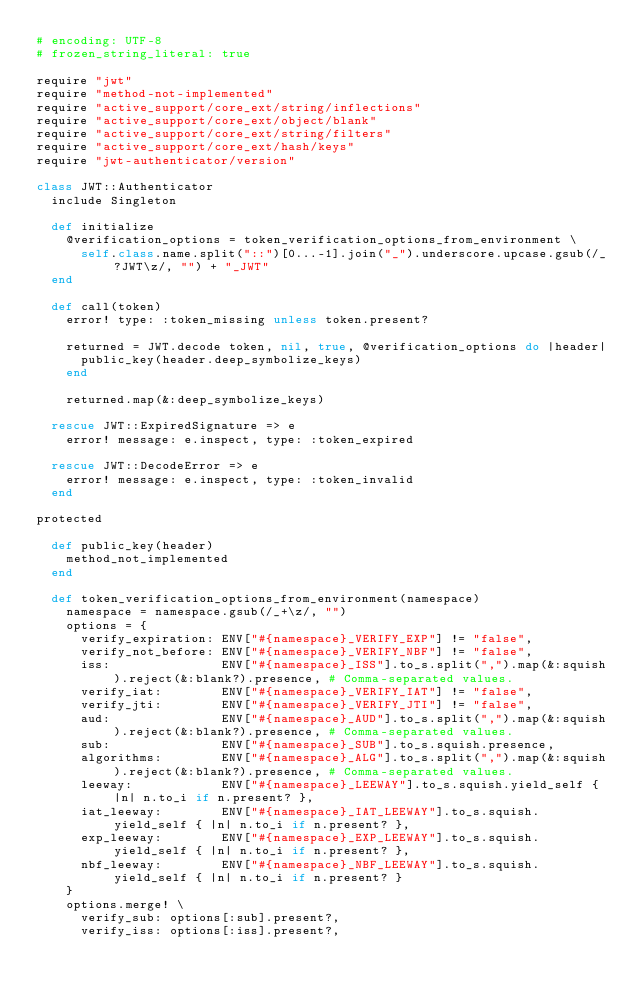<code> <loc_0><loc_0><loc_500><loc_500><_Ruby_># encoding: UTF-8
# frozen_string_literal: true

require "jwt"
require "method-not-implemented"
require "active_support/core_ext/string/inflections"
require "active_support/core_ext/object/blank"
require "active_support/core_ext/string/filters"
require "active_support/core_ext/hash/keys"
require "jwt-authenticator/version"

class JWT::Authenticator
  include Singleton

  def initialize
    @verification_options = token_verification_options_from_environment \
      self.class.name.split("::")[0...-1].join("_").underscore.upcase.gsub(/_?JWT\z/, "") + "_JWT"
  end

  def call(token)
    error! type: :token_missing unless token.present?

    returned = JWT.decode token, nil, true, @verification_options do |header|
      public_key(header.deep_symbolize_keys)
    end

    returned.map(&:deep_symbolize_keys)

  rescue JWT::ExpiredSignature => e
    error! message: e.inspect, type: :token_expired

  rescue JWT::DecodeError => e
    error! message: e.inspect, type: :token_invalid
  end

protected

  def public_key(header)
    method_not_implemented
  end

  def token_verification_options_from_environment(namespace)
    namespace = namespace.gsub(/_+\z/, "")
    options = {
      verify_expiration: ENV["#{namespace}_VERIFY_EXP"] != "false",
      verify_not_before: ENV["#{namespace}_VERIFY_NBF"] != "false",
      iss:               ENV["#{namespace}_ISS"].to_s.split(",").map(&:squish).reject(&:blank?).presence, # Comma-separated values.
      verify_iat:        ENV["#{namespace}_VERIFY_IAT"] != "false",
      verify_jti:        ENV["#{namespace}_VERIFY_JTI"] != "false",
      aud:               ENV["#{namespace}_AUD"].to_s.split(",").map(&:squish).reject(&:blank?).presence, # Comma-separated values.
      sub:               ENV["#{namespace}_SUB"].to_s.squish.presence,
      algorithms:        ENV["#{namespace}_ALG"].to_s.split(",").map(&:squish).reject(&:blank?).presence, # Comma-separated values.
      leeway:            ENV["#{namespace}_LEEWAY"].to_s.squish.yield_self { |n| n.to_i if n.present? },
      iat_leeway:        ENV["#{namespace}_IAT_LEEWAY"].to_s.squish.yield_self { |n| n.to_i if n.present? },
      exp_leeway:        ENV["#{namespace}_EXP_LEEWAY"].to_s.squish.yield_self { |n| n.to_i if n.present? },
      nbf_leeway:        ENV["#{namespace}_NBF_LEEWAY"].to_s.squish.yield_self { |n| n.to_i if n.present? }
    }
    options.merge! \
      verify_sub: options[:sub].present?,
      verify_iss: options[:iss].present?,</code> 